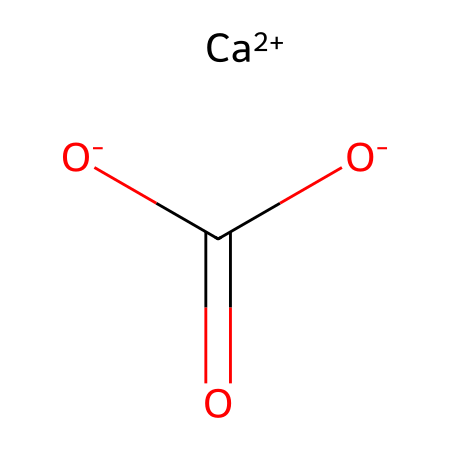What is the chemical name of this compound? The SMILES notation reveals that this compound consists of calcium, carbon, and oxygen atoms in a classic arrangement, known as calcium carbonate.
Answer: calcium carbonate How many oxygen atoms are present in the structure? From the SMILES, we can see that there are three oxygen atoms represented.
Answer: three What is the total number of atoms in this compound? The components include one calcium atom, one carbon atom, and three oxygen atoms, totaling five atoms.
Answer: five Is this compound ionic or covalent? The presence of calcium as a cation and the carbonate ion, which is a polyatomic ion, indicates that the compound is ionic in nature.
Answer: ionic What functional group is present in this compound? The presence of the carbonate part signifies that this compound contains a carbonate functional group, which consists of carbon and oxygen atoms.
Answer: carbonate How many bonds connect the carbon atom to the surrounding atoms? The carbon atom is connected by four bonds: one double bond to one oxygen and two single bonds to the other two oxygen atoms, while it interacts with calcium ionically.
Answer: four Does this compound exhibit any significant polarity characteristics? Given that the compound contains both ionic and polar covalent bonds (between carbon and oxygen), it exhibits some polarity, but overall it is considered ionic.
Answer: ionic 